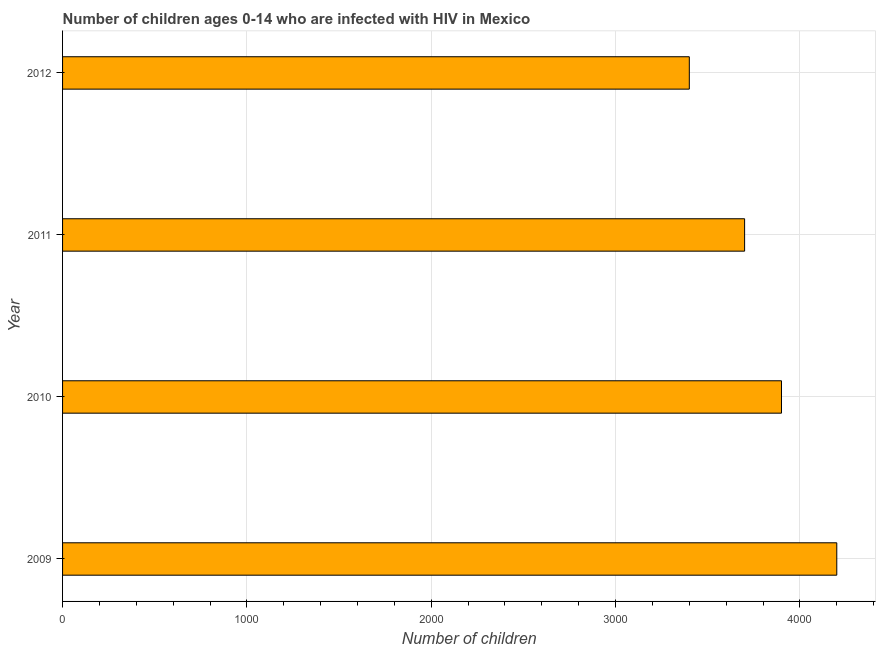Does the graph contain any zero values?
Your answer should be very brief. No. What is the title of the graph?
Provide a short and direct response. Number of children ages 0-14 who are infected with HIV in Mexico. What is the label or title of the X-axis?
Provide a short and direct response. Number of children. What is the label or title of the Y-axis?
Your answer should be compact. Year. What is the number of children living with hiv in 2012?
Your answer should be very brief. 3400. Across all years, what is the maximum number of children living with hiv?
Provide a succinct answer. 4200. Across all years, what is the minimum number of children living with hiv?
Offer a terse response. 3400. What is the sum of the number of children living with hiv?
Ensure brevity in your answer.  1.52e+04. What is the difference between the number of children living with hiv in 2009 and 2010?
Your answer should be compact. 300. What is the average number of children living with hiv per year?
Give a very brief answer. 3800. What is the median number of children living with hiv?
Keep it short and to the point. 3800. What is the ratio of the number of children living with hiv in 2010 to that in 2011?
Your answer should be compact. 1.05. Is the difference between the number of children living with hiv in 2009 and 2012 greater than the difference between any two years?
Give a very brief answer. Yes. What is the difference between the highest and the second highest number of children living with hiv?
Give a very brief answer. 300. What is the difference between the highest and the lowest number of children living with hiv?
Your answer should be very brief. 800. In how many years, is the number of children living with hiv greater than the average number of children living with hiv taken over all years?
Offer a very short reply. 2. How many years are there in the graph?
Ensure brevity in your answer.  4. What is the Number of children of 2009?
Ensure brevity in your answer.  4200. What is the Number of children of 2010?
Your answer should be very brief. 3900. What is the Number of children in 2011?
Your answer should be very brief. 3700. What is the Number of children in 2012?
Your answer should be very brief. 3400. What is the difference between the Number of children in 2009 and 2010?
Your answer should be very brief. 300. What is the difference between the Number of children in 2009 and 2012?
Keep it short and to the point. 800. What is the difference between the Number of children in 2010 and 2012?
Offer a terse response. 500. What is the difference between the Number of children in 2011 and 2012?
Your answer should be compact. 300. What is the ratio of the Number of children in 2009 to that in 2010?
Your answer should be very brief. 1.08. What is the ratio of the Number of children in 2009 to that in 2011?
Your answer should be compact. 1.14. What is the ratio of the Number of children in 2009 to that in 2012?
Make the answer very short. 1.24. What is the ratio of the Number of children in 2010 to that in 2011?
Offer a terse response. 1.05. What is the ratio of the Number of children in 2010 to that in 2012?
Offer a very short reply. 1.15. What is the ratio of the Number of children in 2011 to that in 2012?
Give a very brief answer. 1.09. 